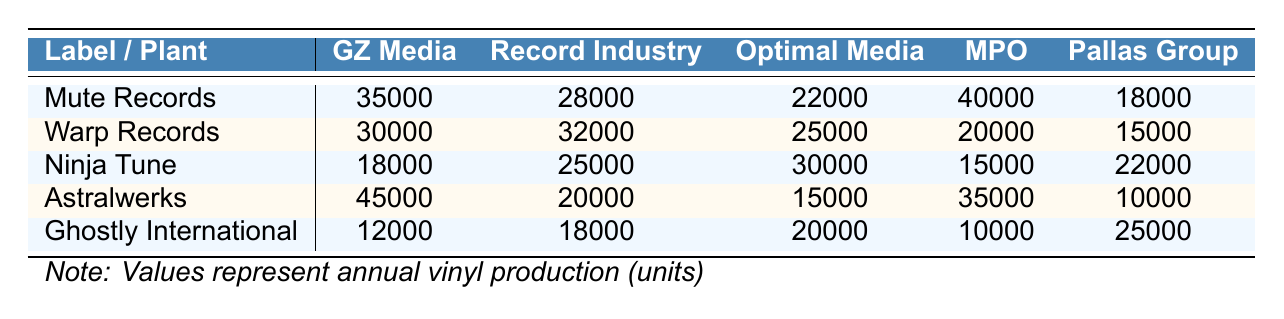What is the highest annual vinyl production among the labels? The table shows the annual vinyl production for each label. By scanning the values, Mute Records has the highest production with 35,000 units.
Answer: 35000 Which pressing plant has the lowest production for Warp Records? For Warp Records, the production values across plants are: GZ Media (30,000), Record Industry (32,000), Optimal Media (25,000), MPO (20,000), and Pallas Group (15,000). The lowest value here is 15,000 units at Pallas Group.
Answer: Pallas Group How many more units does Astralwerks produce compared to Ghostly International? The production for Astralwerks is 45,000 units while Ghostly International produces 12,000 units. The difference is 45,000 - 12,000 = 33,000 units.
Answer: 33000 Is Optimal Media the plant with the highest production for any label? The highest production values for each plant: GZ Media (35,000 for Mute Records), Record Industry (32,000 for Warp Records), Optimal Media (30,000 for Ninja Tune), MPO (45,000 for Astralwerks), Pallas Group (25,000 for Ghostly International). The highest from Optimal Media is 30,000, which is lower than 35,000 and 45,000 from other plants, so it is not the highest.
Answer: No What is the average annual production across all labels for GZ Media? The values for GZ Media are 35,000 (Mute), 30,000 (Warp), 18,000 (Ninja), 45,000 (Astralwerks), and 12,000 (Ghostly). The average is computed as (35,000 + 30,000 + 18,000 + 45,000 + 12,000) / 5 = 140,000 / 5 = 28,000.
Answer: 28000 Which label has the lowest production across all plants? Looking at the data, Ghostly International has the lowest production at 12,000 units. Comparing with other labels: Mute (35,000), Warp (30,000), Ninja (18,000), and Astralwerks (45,000), it is confirmed.
Answer: Ghostly International What is the total vinyl production for Ninja Tune? The annual production values for Ninja Tune at different plants are 18,000 (GZ Media), 25,000 (Record Industry), 30,000 (Optimal Media), 15,000 (MPO), and 22,000 (Pallas Group). Totaling these gives: 18,000 + 25,000 + 30,000 + 15,000 + 22,000 = 110,000 units.
Answer: 110000 Which plant produces more vinyl on average: GZ Media or MPO? For GZ Media: (35,000 + 30,000 + 18,000 + 45,000 + 12,000) / 5 = 28,000. For MPO: (40,000 + 20,000 + 15,000 + 35,000 + 10,000) / 5 = 26,000. GZ Media's average is higher than MPO's, so GZ Media produces more.
Answer: GZ Media If all labels partnered with Pallas Group, what would their combined production be? The production values for all labels at Pallas Group are: 18,000 (Mute), 15,000 (Warp), 22,000 (Ninja), 10,000 (Astralwerks), and 25,000 (Ghostly). Combining these gives: 18,000 + 15,000 + 22,000 + 10,000 + 25,000 = 90,000.
Answer: 90000 